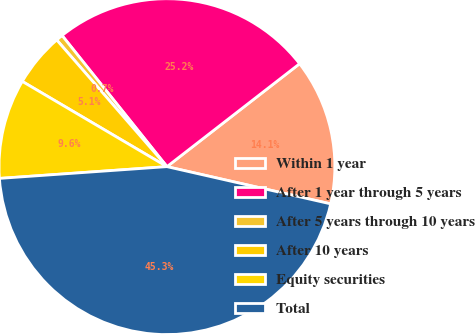Convert chart to OTSL. <chart><loc_0><loc_0><loc_500><loc_500><pie_chart><fcel>Within 1 year<fcel>After 1 year through 5 years<fcel>After 5 years through 10 years<fcel>After 10 years<fcel>Equity securities<fcel>Total<nl><fcel>14.06%<fcel>25.23%<fcel>0.66%<fcel>5.13%<fcel>9.59%<fcel>45.32%<nl></chart> 